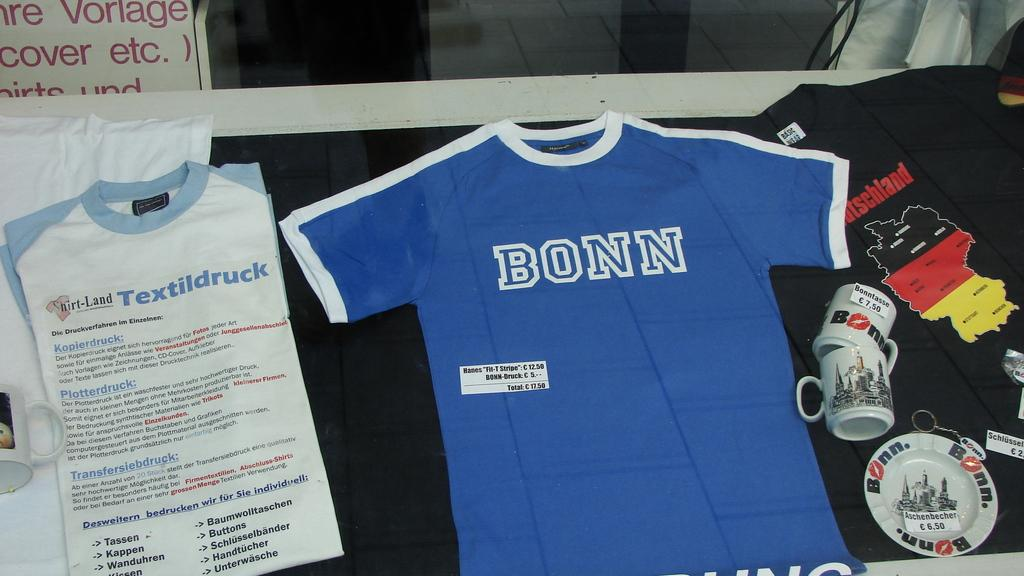Provide a one-sentence caption for the provided image. A Bonn t-shirt is displayed on the table. 